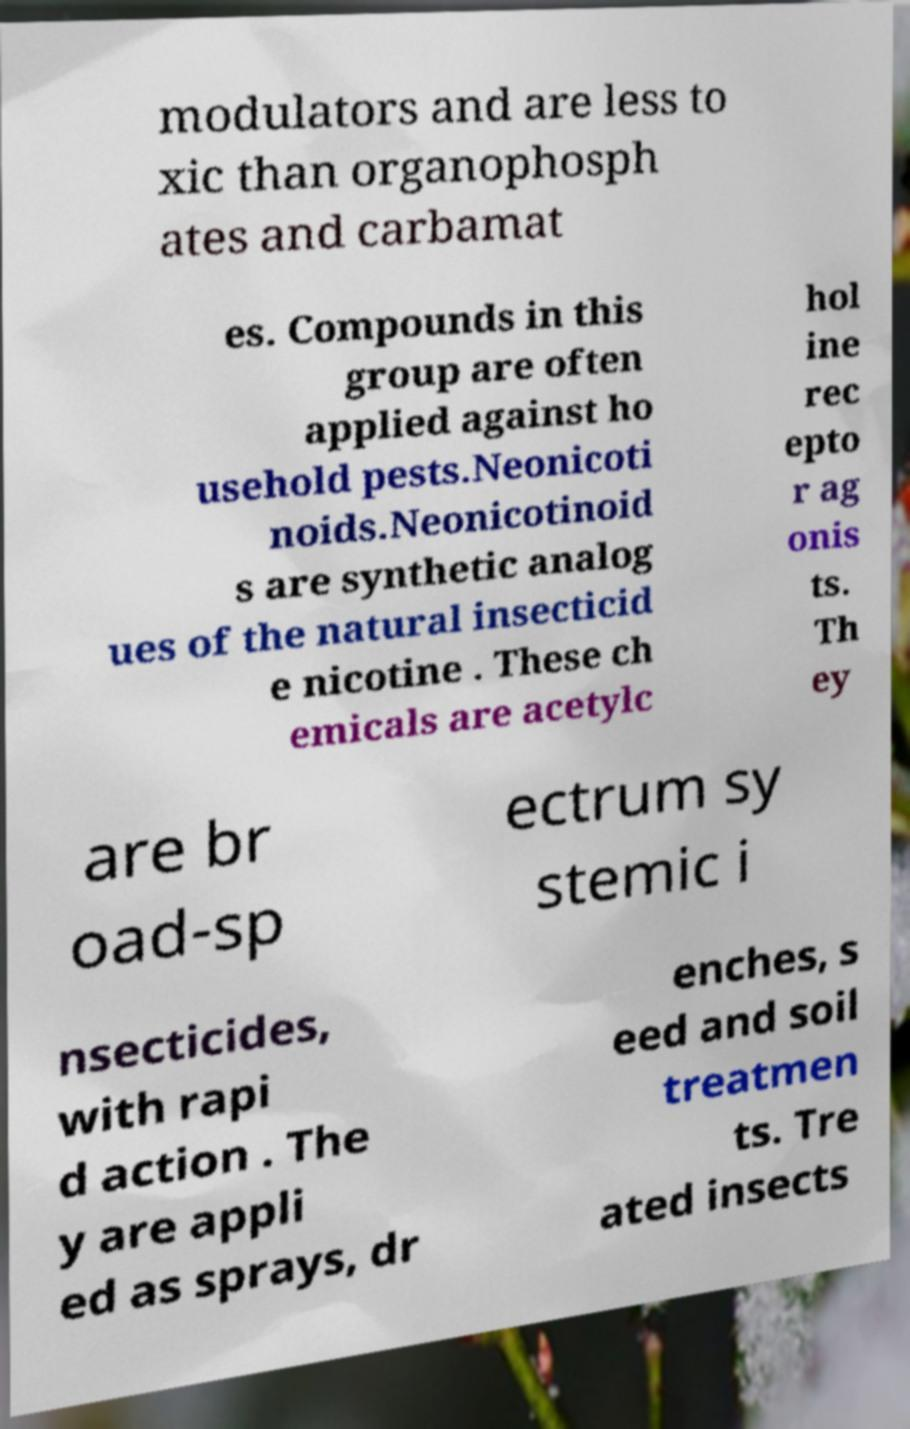Can you read and provide the text displayed in the image?This photo seems to have some interesting text. Can you extract and type it out for me? modulators and are less to xic than organophosph ates and carbamat es. Compounds in this group are often applied against ho usehold pests.Neonicoti noids.Neonicotinoid s are synthetic analog ues of the natural insecticid e nicotine . These ch emicals are acetylc hol ine rec epto r ag onis ts. Th ey are br oad-sp ectrum sy stemic i nsecticides, with rapi d action . The y are appli ed as sprays, dr enches, s eed and soil treatmen ts. Tre ated insects 